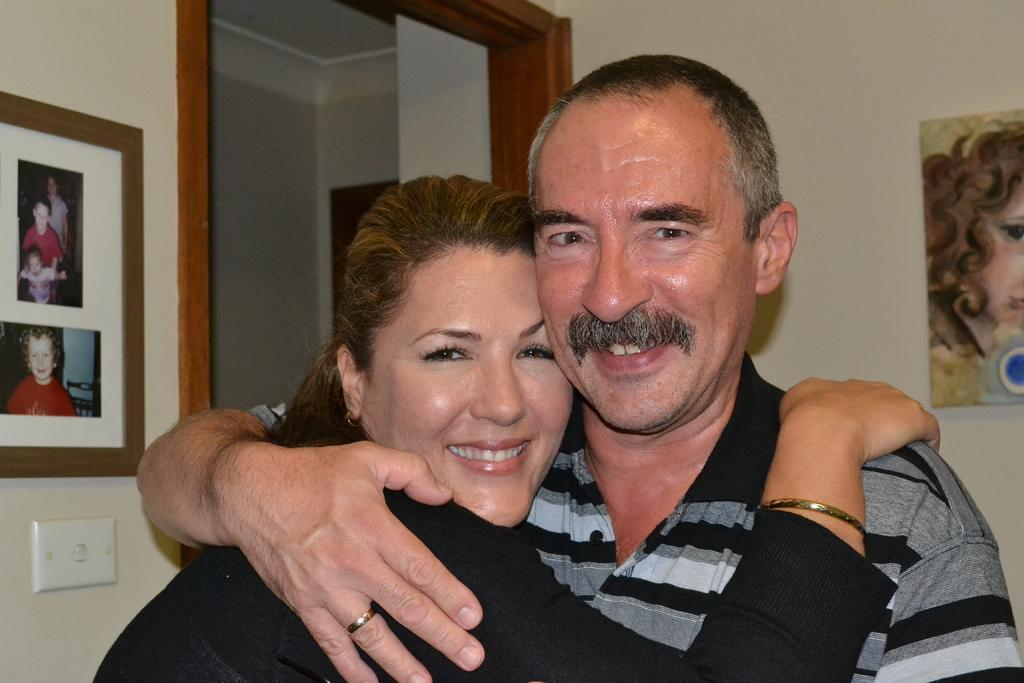Who are the people in the image? There is a man and a woman in the image. Where are the man and woman located in the image? The man and woman are in the center of the image. What can be seen on the wall in the image? There are portraits on the wall. What architectural feature is visible in the background of the image? There appears to be a door in the background of the image. What type of banana is the man using to alleviate his pain in the image? There is no banana present in the image, nor is there any indication of pain or its alleviation. 